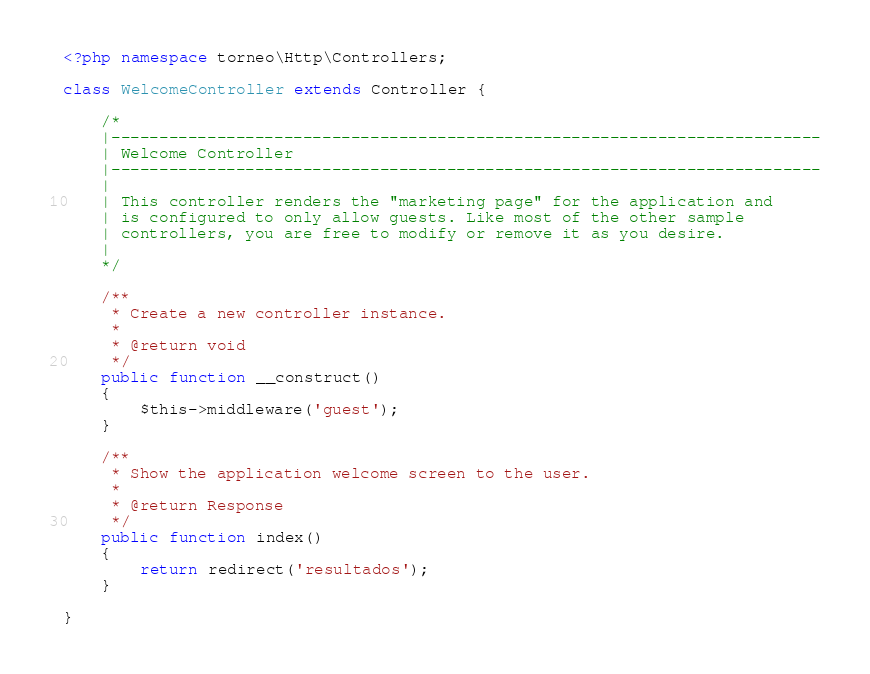<code> <loc_0><loc_0><loc_500><loc_500><_PHP_><?php namespace torneo\Http\Controllers;

class WelcomeController extends Controller {

	/*
	|--------------------------------------------------------------------------
	| Welcome Controller
	|--------------------------------------------------------------------------
	|
	| This controller renders the "marketing page" for the application and
	| is configured to only allow guests. Like most of the other sample
	| controllers, you are free to modify or remove it as you desire.
	|
	*/

	/**
	 * Create a new controller instance.
	 *
	 * @return void
	 */
	public function __construct()
	{
		$this->middleware('guest');
	}

	/**
	 * Show the application welcome screen to the user.
	 *
	 * @return Response
	 */
	public function index()
	{
		return redirect('resultados');
	}

}
</code> 